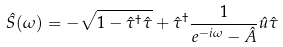Convert formula to latex. <formula><loc_0><loc_0><loc_500><loc_500>\hat { S } ( \omega ) = - \sqrt { 1 - \hat { \tau } ^ { \dagger } \hat { \tau } } + \hat { \tau } ^ { \dagger } \frac { 1 } { e ^ { - i \omega } - \hat { A } } \hat { u } \hat { \tau }</formula> 